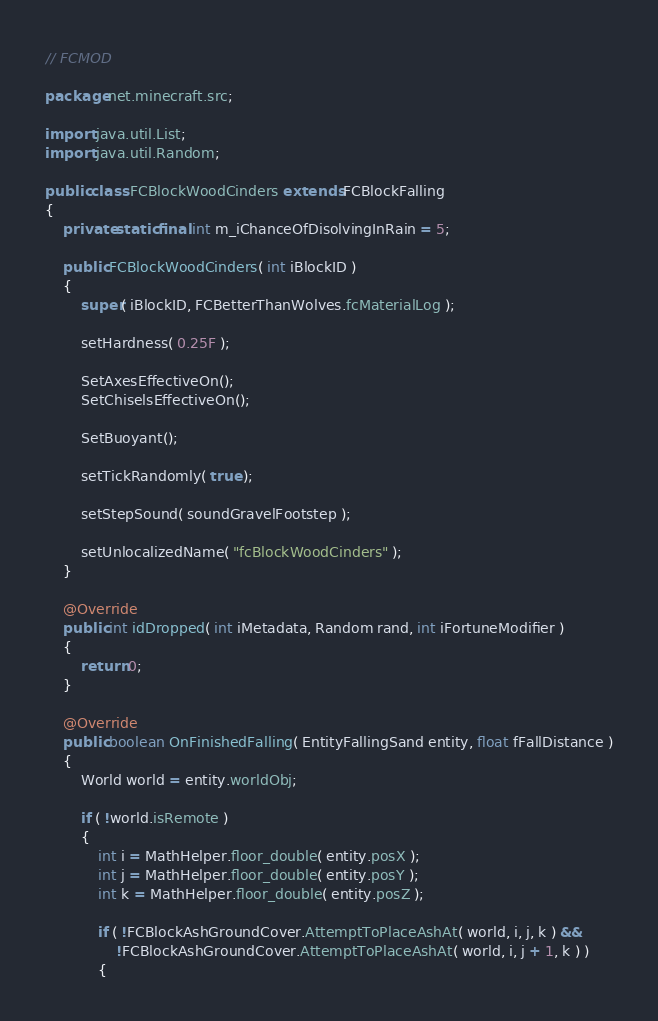<code> <loc_0><loc_0><loc_500><loc_500><_Java_>// FCMOD

package net.minecraft.src;

import java.util.List;
import java.util.Random;

public class FCBlockWoodCinders extends FCBlockFalling
{
	private static final int m_iChanceOfDisolvingInRain = 5;
	
    public FCBlockWoodCinders( int iBlockID )
    {
        super( iBlockID, FCBetterThanWolves.fcMaterialLog );
        
        setHardness( 0.25F );
        
		SetAxesEffectiveOn();
		SetChiselsEffectiveOn();
		
        SetBuoyant();        
        
        setTickRandomly( true );
		
        setStepSound( soundGravelFootstep );
        
        setUnlocalizedName( "fcBlockWoodCinders" );        
    }
    
    @Override
    public int idDropped( int iMetadata, Random rand, int iFortuneModifier )
    {
        return 0;
    }
    
    @Override
    public boolean OnFinishedFalling( EntityFallingSand entity, float fFallDistance )
    {
    	World world = entity.worldObj;
    	
        if ( !world.isRemote )
        {
	        int i = MathHelper.floor_double( entity.posX );
	        int j = MathHelper.floor_double( entity.posY );
	        int k = MathHelper.floor_double( entity.posZ );
	        
	        if ( !FCBlockAshGroundCover.AttemptToPlaceAshAt( world, i, j, k ) &&
	        	!FCBlockAshGroundCover.AttemptToPlaceAshAt( world, i, j + 1, k ) )
	        {</code> 